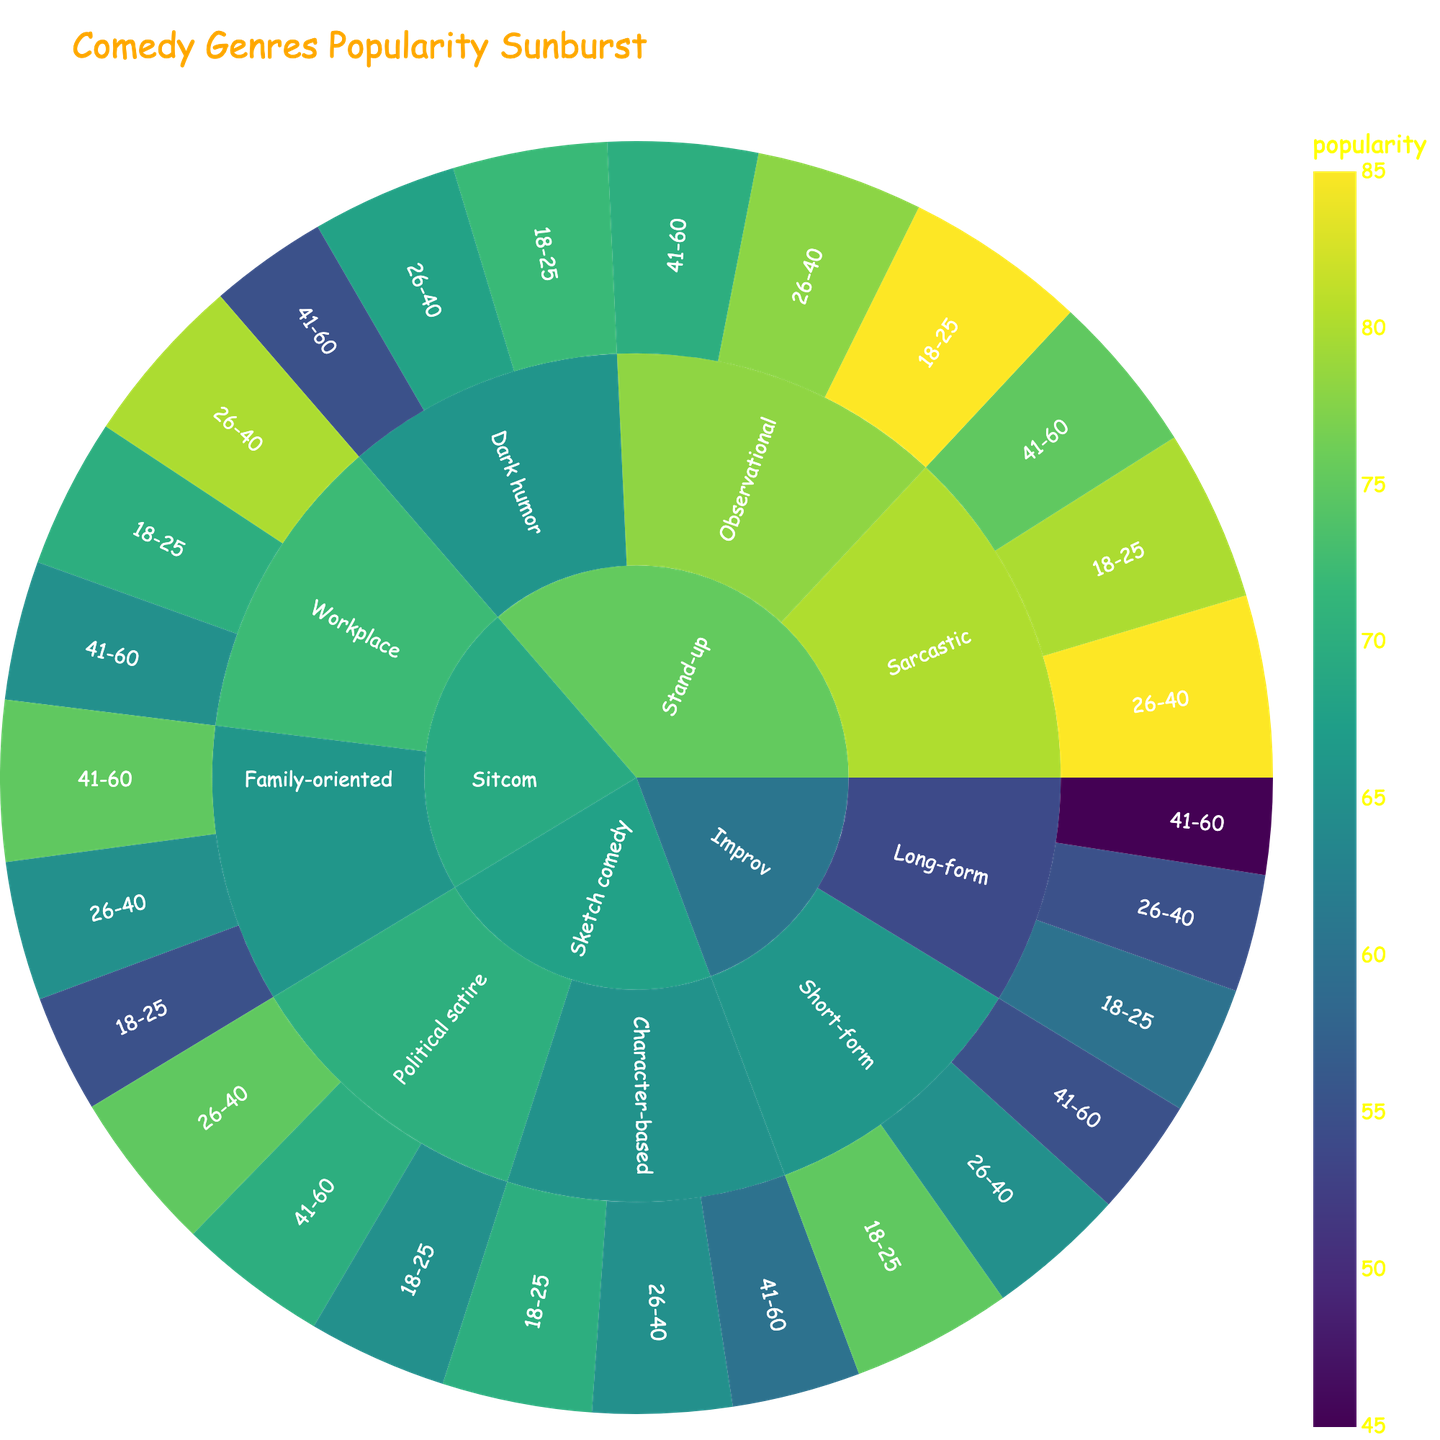What's the title of the plot? The title of the plot is typically displayed at the top center of a sunburst plot.
Answer: Comedy Genres Popularity Sunburst Which age group finds Observational stand-up most popular? From the sunburst plot, look at the Observational subgenre under Stand-up and observe the segment with the highest value.
Answer: 18-25 What's the least popular subgenre among the age group 41-60? In the 41-60 age group, check the values associated with all subgenres and find the one with the lowest value.
Answer: Improv, Long-form How does the popularity of Dark humor compare between the 18-25 and 41-60 age groups? Find the Dark humor subgenre under Stand-up and compare the popularity ratings for the 18-25 and 41-60 age groups.
Answer: 72 for 18-25, 55 for 41-60 What's the average popularity of Short-form Improv across all age groups? For Short-form Improv, add the popularity values for 18-25, 26-40, and 41-60, then divide by 3. (75 + 65 + 55) / 3 = 65
Answer: 65 Which genre is most popular among the age group 26-40? Look across all genres to find which one has the highest popularity value in the 26-40 age group.
Answer: Stand-up, Sarcastic What is the popularity difference between Political satire and Character-based sketch comedy in the 41-60 age group? Subtract the popularity value of Character-based from Political satire for the 41-60 age group. (70 - 60) = 10
Answer: 10 Which subgenre has the highest overall popularity? Identify the subgenre with the highest value among all age groups in the sunburst plot.
Answer: Observational, 18-25 What's the total popularity of Family-oriented Sitcoms across all age groups? Sum the popularity values of Family-oriented Sitcoms for the 18-25, 26-40, and 41-60 age groups. (55 + 65 + 75) = 195
Answer: 195 